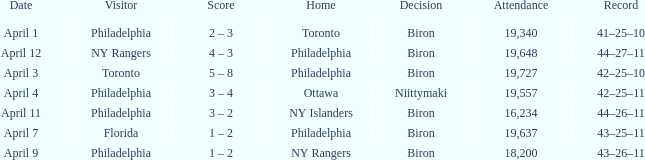What was the flyers' record when the visitors were florida? 43–25–11. 